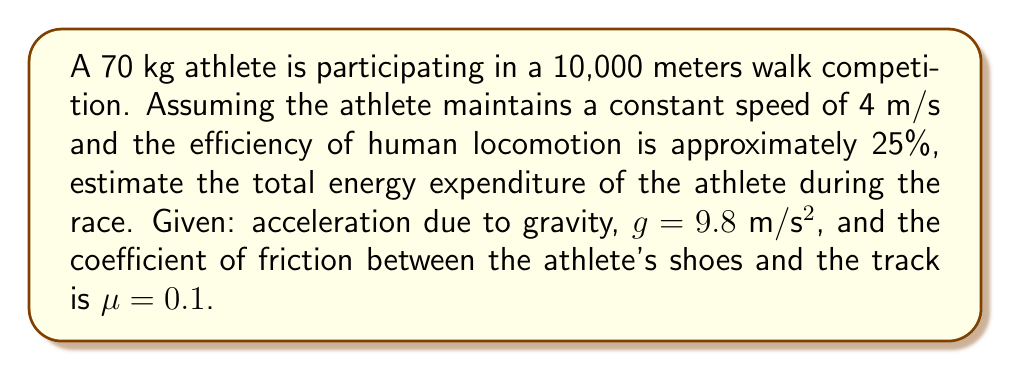Can you answer this question? To estimate the energy expenditure, we'll use thermodynamic principles and follow these steps:

1) First, calculate the work done against friction:
   Force of friction = μ * m * g
   $F_f = 0.1 * 70 \text{ kg} * 9.8 \text{ m/s}^2 = 68.6 \text{ N}$

2) Work done against friction:
   $W_f = F_f * d = 68.6 \text{ N} * 10,000 \text{ m} = 686,000 \text{ J}$

3) In an ideal scenario, this would be the energy expended. However, the human body is not 100% efficient. Given the efficiency of 25%, we need to account for this:

   $\text{Total Energy Expenditure} = \frac{\text{Work done}}{\text{Efficiency}}$

   $\text{Total Energy Expenditure} = \frac{686,000 \text{ J}}{0.25} = 2,744,000 \text{ J}$

4) Convert joules to kilocalories (commonly used unit for energy in nutrition):
   1 kilocalorie = 4184 J

   $\text{Energy in kcal} = \frac{2,744,000 \text{ J}}{4184 \text{ J/kcal}} \approx 656 \text{ kcal}$

Therefore, the estimated energy expenditure for the athlete during the 10,000 meters walk is approximately 656 kcal.
Answer: 656 kcal 